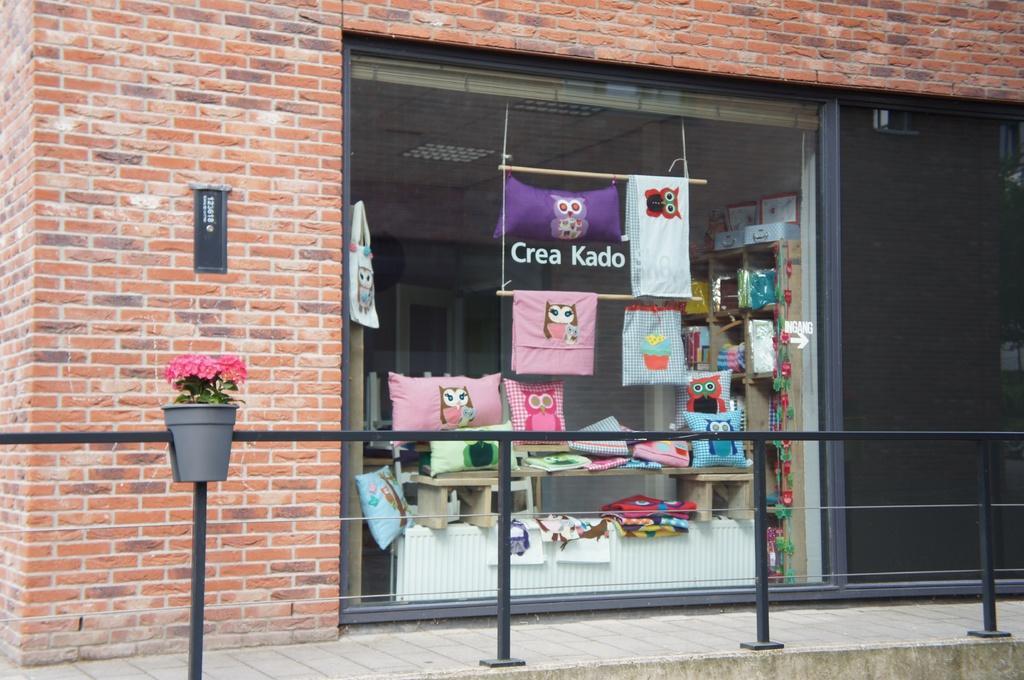In one or two sentences, can you explain what this image depicts? In this picture I can see the flowers and plants on the left side, at the bottom there is an iron grill, in the middle there is a glass wall, inside this glass wall I can see few pillows, it looks like a store. I can see the brick wall. 